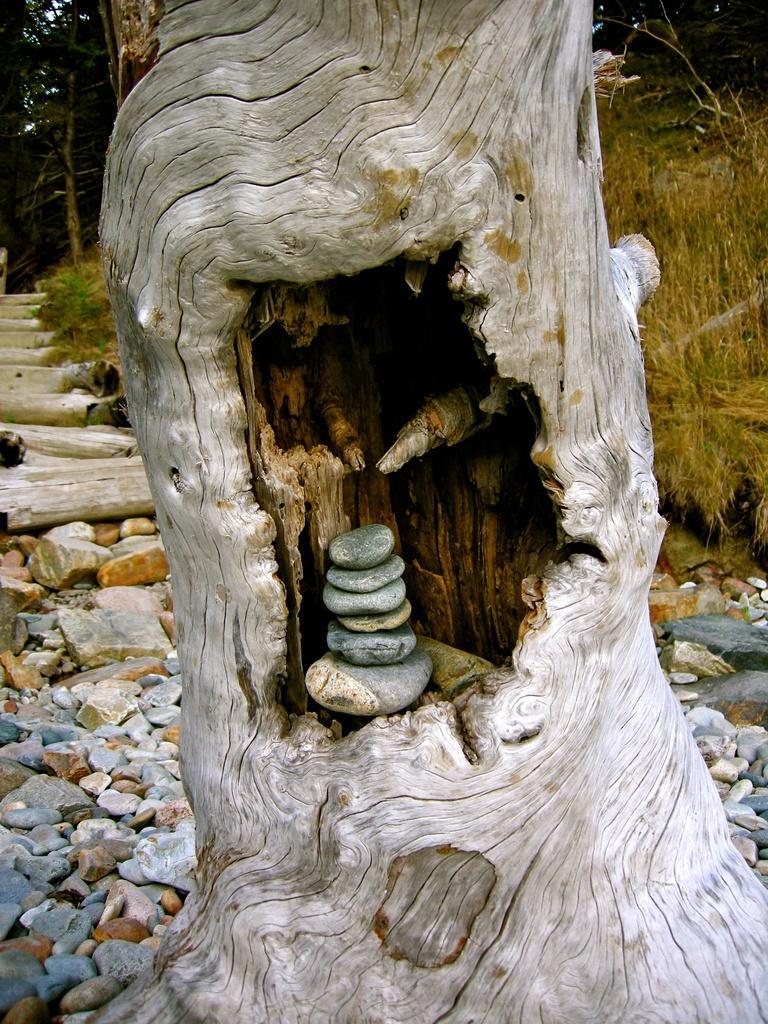Could you give a brief overview of what you see in this image? In this image we can see the hole to the trunk where stones are kept. In the background, we can see a few more stones on the ground, we can see steps, grass and the trees. 